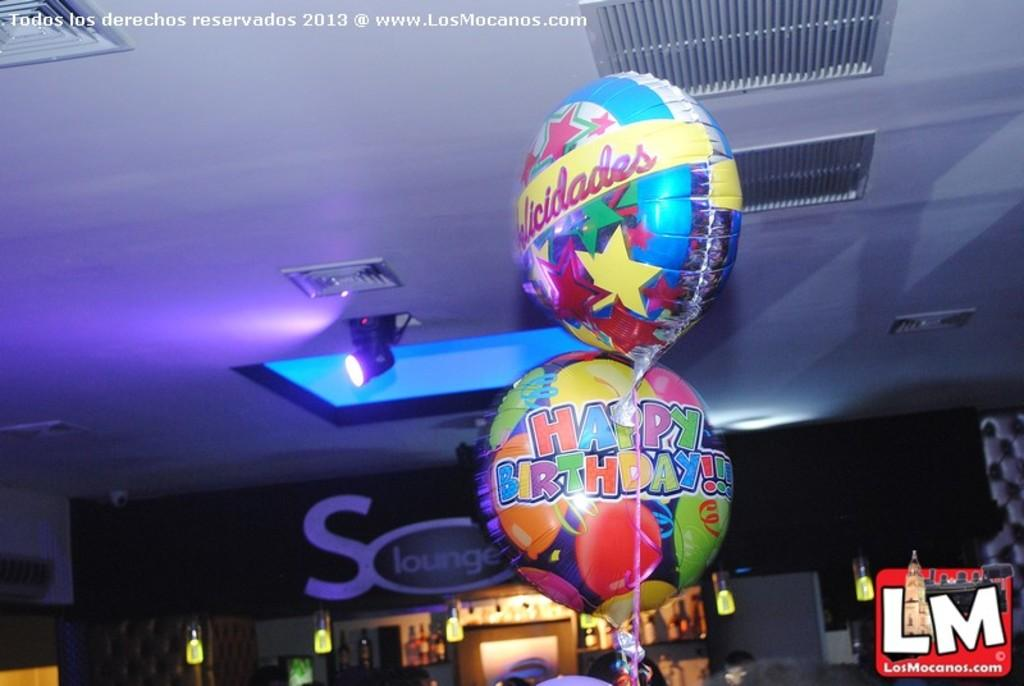<image>
Create a compact narrative representing the image presented. A colorful party balloon displays the message Happy Birthday! 